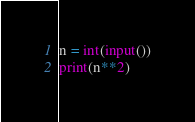<code> <loc_0><loc_0><loc_500><loc_500><_Python_>n = int(input())
print(n**2)
</code> 